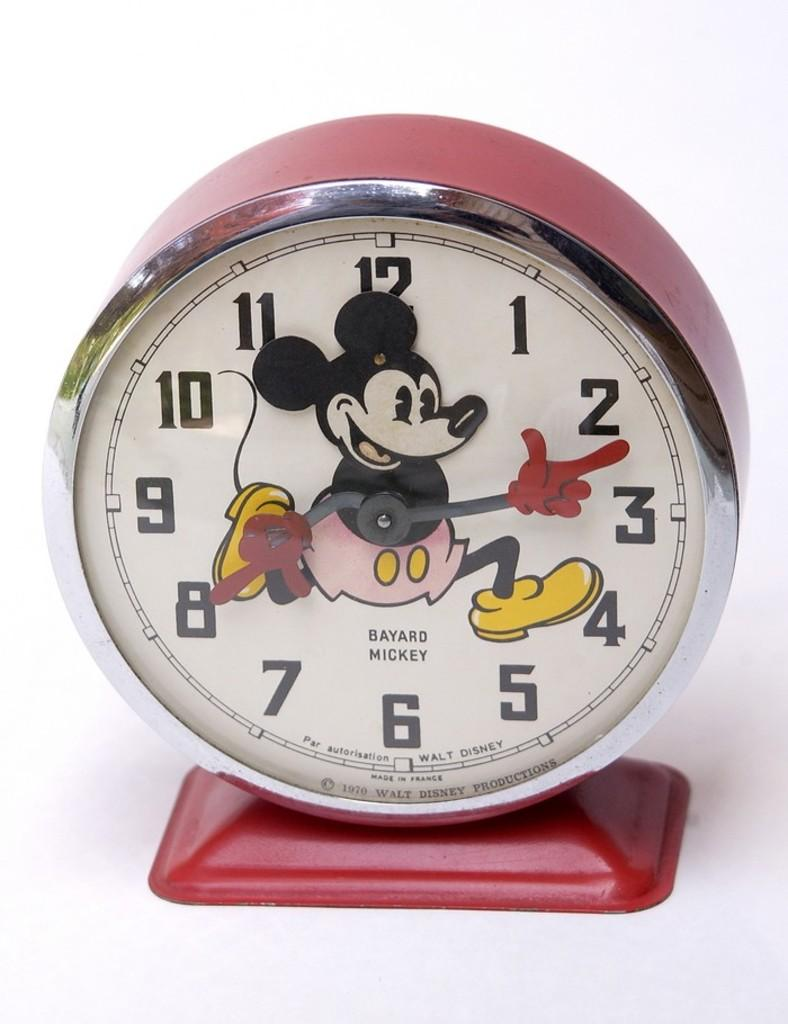Provide a one-sentence caption for the provided image. A Mickey Mouse clock that was made in France. 